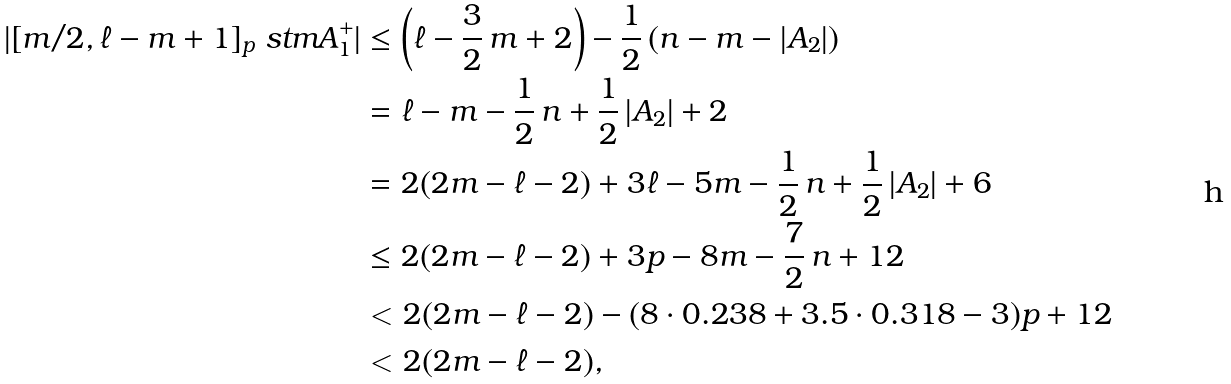Convert formula to latex. <formula><loc_0><loc_0><loc_500><loc_500>| [ m / 2 , \ell - m + 1 ] _ { p } \ s t m A _ { 1 } ^ { + } | & \leq \left ( \ell - \frac { 3 } { 2 } \, m + 2 \right ) - \frac { 1 } { 2 } \, ( n - m - | A _ { 2 } | ) \\ & = \ell - m - \frac { 1 } { 2 } \, n + \frac { 1 } { 2 } \, | A _ { 2 } | + 2 \\ & = 2 ( 2 m - \ell - 2 ) + 3 \ell - 5 m - \frac { 1 } { 2 } \, n + \frac { 1 } { 2 } \, | A _ { 2 } | + 6 \\ & \leq 2 ( 2 m - \ell - 2 ) + 3 p - 8 m - \frac { 7 } { 2 } \, n + 1 2 \\ & < 2 ( 2 m - \ell - 2 ) - ( 8 \cdot 0 . 2 3 8 + 3 . 5 \cdot 0 . 3 1 8 - 3 ) p + 1 2 \\ & < 2 ( 2 m - \ell - 2 ) ,</formula> 